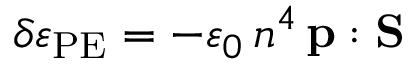Convert formula to latex. <formula><loc_0><loc_0><loc_500><loc_500>\delta \varepsilon _ { P E } = - \varepsilon _ { 0 } \, n ^ { 4 } \, p \colon S</formula> 